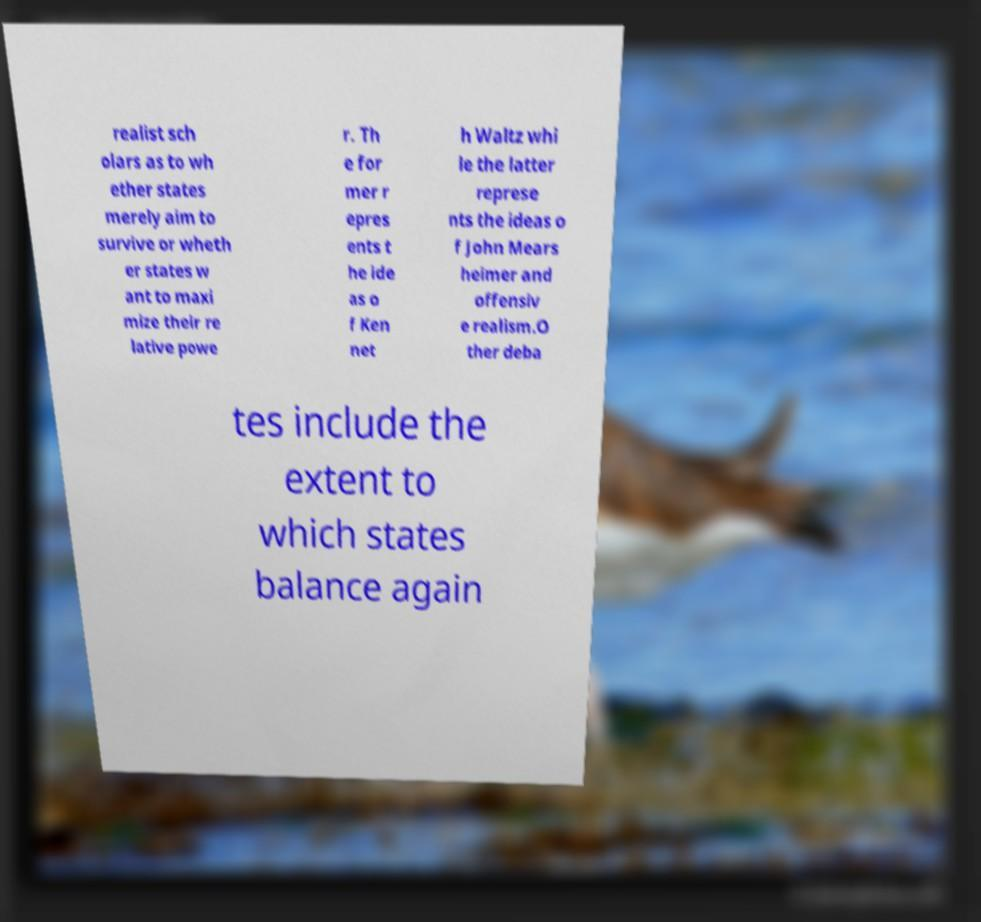There's text embedded in this image that I need extracted. Can you transcribe it verbatim? realist sch olars as to wh ether states merely aim to survive or wheth er states w ant to maxi mize their re lative powe r. Th e for mer r epres ents t he ide as o f Ken net h Waltz whi le the latter represe nts the ideas o f John Mears heimer and offensiv e realism.O ther deba tes include the extent to which states balance again 